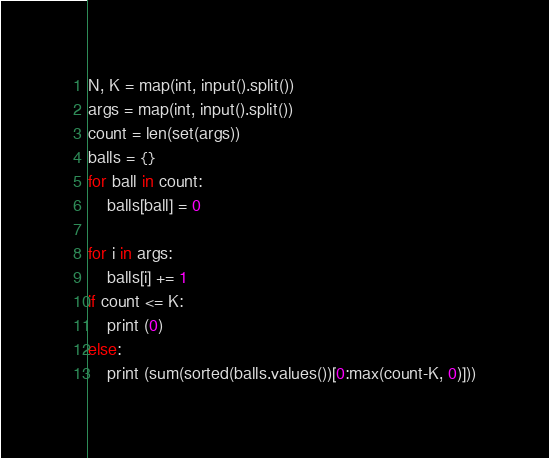<code> <loc_0><loc_0><loc_500><loc_500><_Python_>N, K = map(int, input().split())
args = map(int, input().split())
count = len(set(args))
balls = {}
for ball in count:
    balls[ball] = 0

for i in args:
    balls[i] += 1
if count <= K:
    print (0)
else:
    print (sum(sorted(balls.values())[0:max(count-K, 0)]))
</code> 